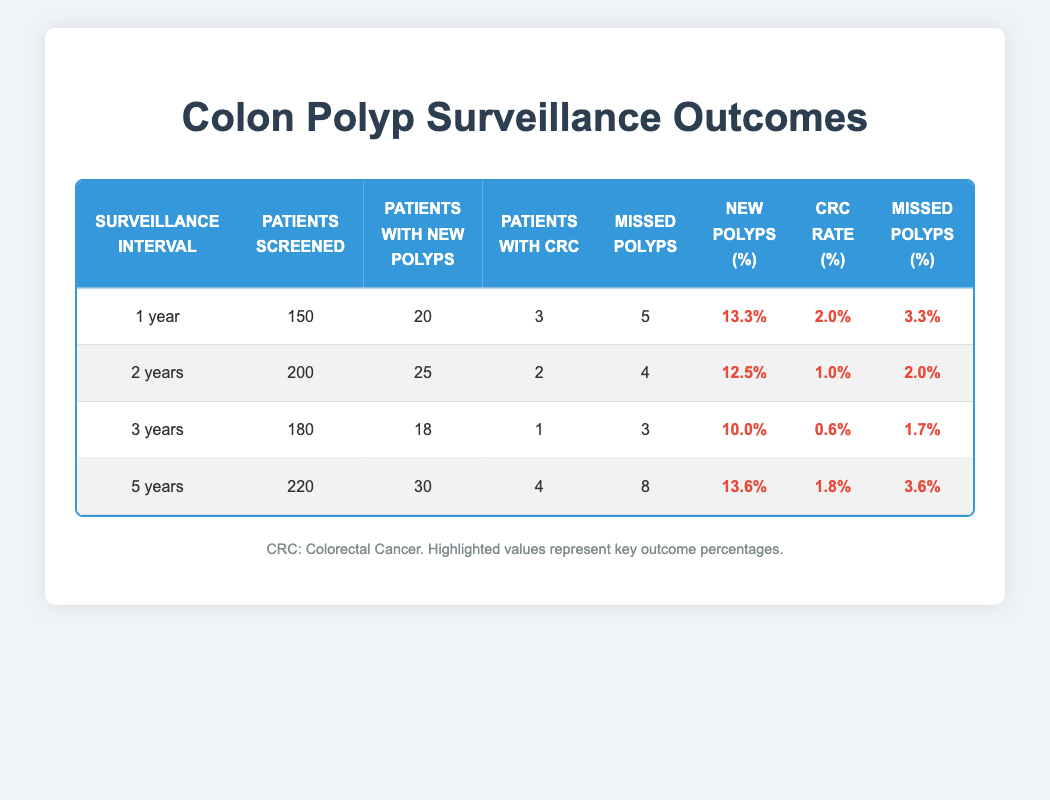What is the percentage of new polyps for patients surveilled every year? In the row for the 1-year surveillance interval, the highlighted value for new polyps percentage is 13.3%.
Answer: 13.3% How many patients were screened under the 5-year interval? Under the 5-year surveillance interval, the table states that 220 patients were screened.
Answer: 220 Which surveillance interval has the highest missed polyps percentage? Comparing the highlighted missed polyps percentages between intervals, 5 years has 3.6%, which is higher than all others: 3.3% (1 year), 2.0% (2 years), and 1.7% (3 years).
Answer: 5 years What is the CRC rate among patients who followed a 3-year surveillance interval? The highlighted CRC rate for the 3-year interval is 0.6%, as indicated in the table.
Answer: 0.6% Calculate the average percentage of new polyps across all intervals. To find the average, sum up the new polyps percentages: 13.3 + 12.5 + 10.0 + 13.6 = 49.4. Divide by the number of intervals (4), giving 49.4 / 4 = 12.35.
Answer: 12.35% Did the 2-year interval have a higher CRC rate than the 1-year interval? The CRC rate for the 2-year interval is 1.0%, which is lower compared to the 1-year interval's CRC rate of 2.0%. Therefore, the statement is false.
Answer: No Which interval had the lowest rate of new polyps? The 3-year interval has the lowest new polyps percentage at 10.0%, lower than all other intervals (1 year: 13.3%, 2 years: 12.5%, 5 years: 13.6%).
Answer: 3 years If we compare the surveillance intervals, how many total patients had CRC? Total CRC cases: 3 (1 year) + 2 (2 years) + 1 (3 years) + 4 (5 years) = 10.
Answer: 10 Which interval had the fewest patients with new polyps? The 3-year interval recorded only 18 patients with new polyps, fewer than any other intervals (1 year: 20, 2 years: 25, 5 years: 30).
Answer: 3 years 